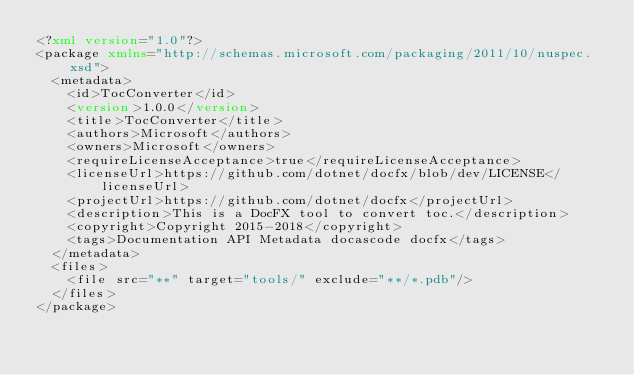Convert code to text. <code><loc_0><loc_0><loc_500><loc_500><_XML_><?xml version="1.0"?>
<package xmlns="http://schemas.microsoft.com/packaging/2011/10/nuspec.xsd">
  <metadata>
    <id>TocConverter</id>
    <version>1.0.0</version>
    <title>TocConverter</title>
    <authors>Microsoft</authors>
    <owners>Microsoft</owners>
    <requireLicenseAcceptance>true</requireLicenseAcceptance>
    <licenseUrl>https://github.com/dotnet/docfx/blob/dev/LICENSE</licenseUrl>
    <projectUrl>https://github.com/dotnet/docfx</projectUrl>
    <description>This is a DocFX tool to convert toc.</description>
    <copyright>Copyright 2015-2018</copyright>
    <tags>Documentation API Metadata docascode docfx</tags>
  </metadata>
  <files>
    <file src="**" target="tools/" exclude="**/*.pdb"/>
  </files>
</package></code> 